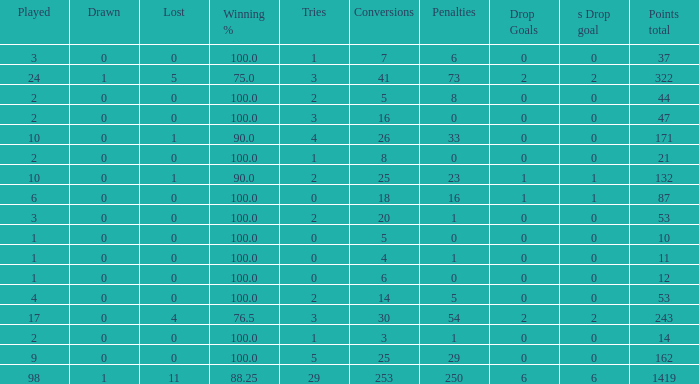What is the least number of penalties he got when his point total was over 1419 in more than 98 games? None. 